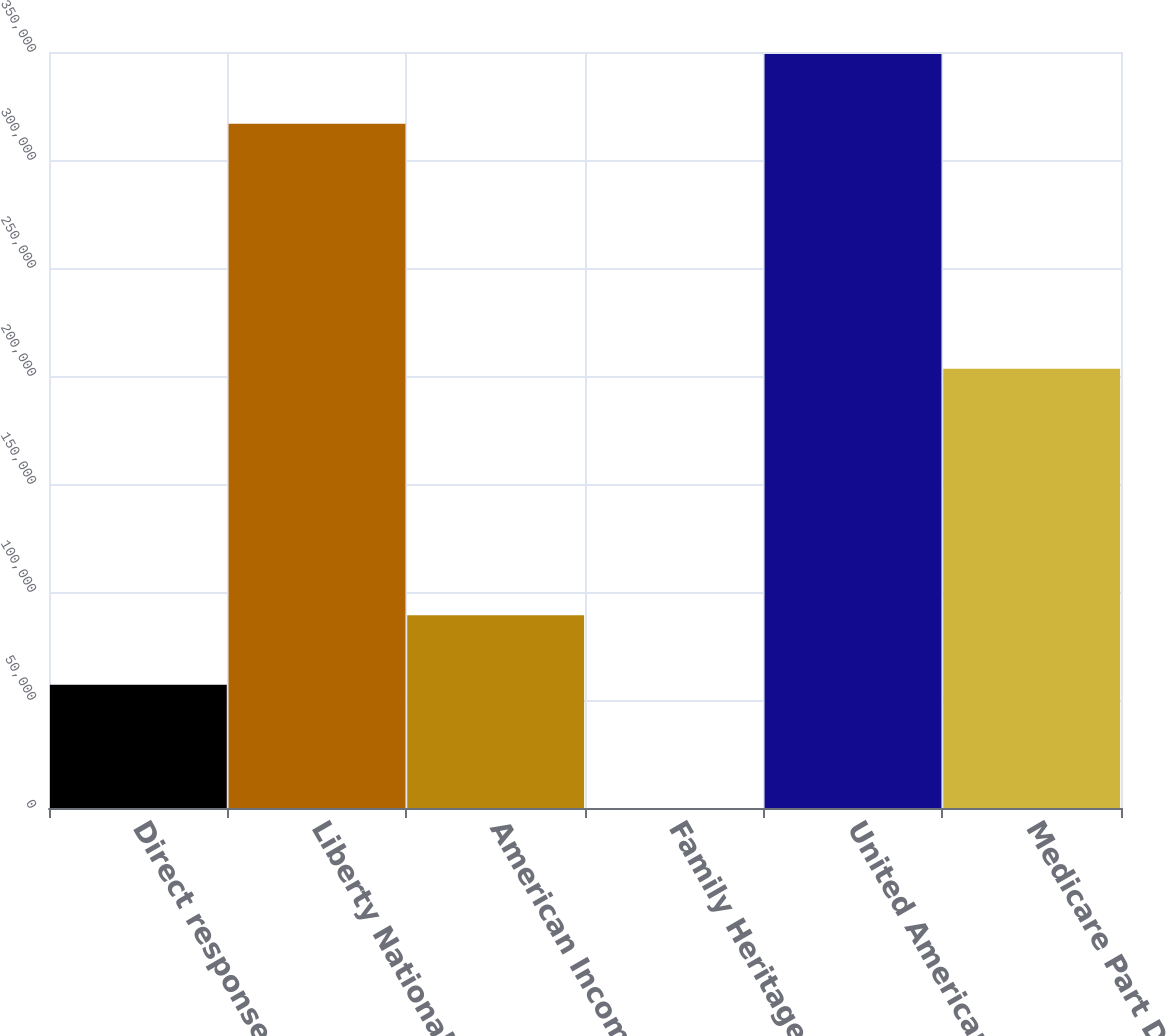Convert chart to OTSL. <chart><loc_0><loc_0><loc_500><loc_500><bar_chart><fcel>Direct response<fcel>Liberty National<fcel>American Income<fcel>Family Heritage<fcel>United American<fcel>Medicare Part D<nl><fcel>57014<fcel>316839<fcel>89252.2<fcel>1.12<fcel>349077<fcel>203340<nl></chart> 